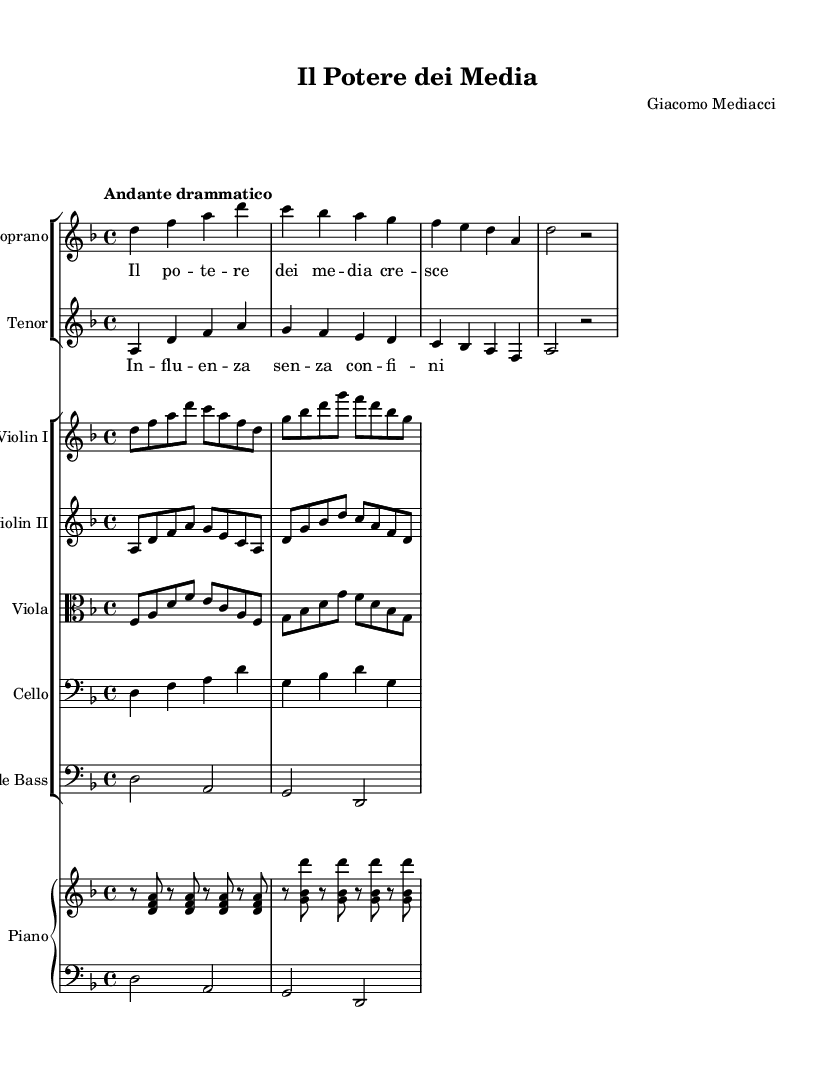What is the key signature of this music? The key signature is indicated in the global section at the beginning of the score, which specifies D minor. D minor has one flat (B flat).
Answer: D minor What is the time signature of this music? The time signature is also found in the global section, depicted as 4/4, meaning there are four beats in each measure.
Answer: 4/4 What is the tempo marking for this piece? The tempo marking "Andante drammatico" is located in the global section, describing a moderately slow and dramatic pace.
Answer: Andante drammatico How many measures does the soprano part contain? By examining the soprano part, it has a total of four measures, as indicated by the separation between them with vertical lines.
Answer: 4 What instruments are present in this music? The score lists the instruments, with both vocal parts (soprano and tenor) and a full orchestra including violins, viola, cello, double bass, and piano.
Answer: Soprano, Tenor, Violin I, Violin II, Viola, Cello, Double Bass, Piano How does the tenor melody relate to the soprano melody? The tenor melody complements the soprano melody by providing a harmonic and contrasting line, creating a dialogue typical in opera. This requires considering their interdependence and voice leading.
Answer: Complementary dialogue What is the main theme represented in the lyrics? The lyrics express themes of media power and influence, highlighting the subject matter's dramatic and societal implications.
Answer: Media power and influence 